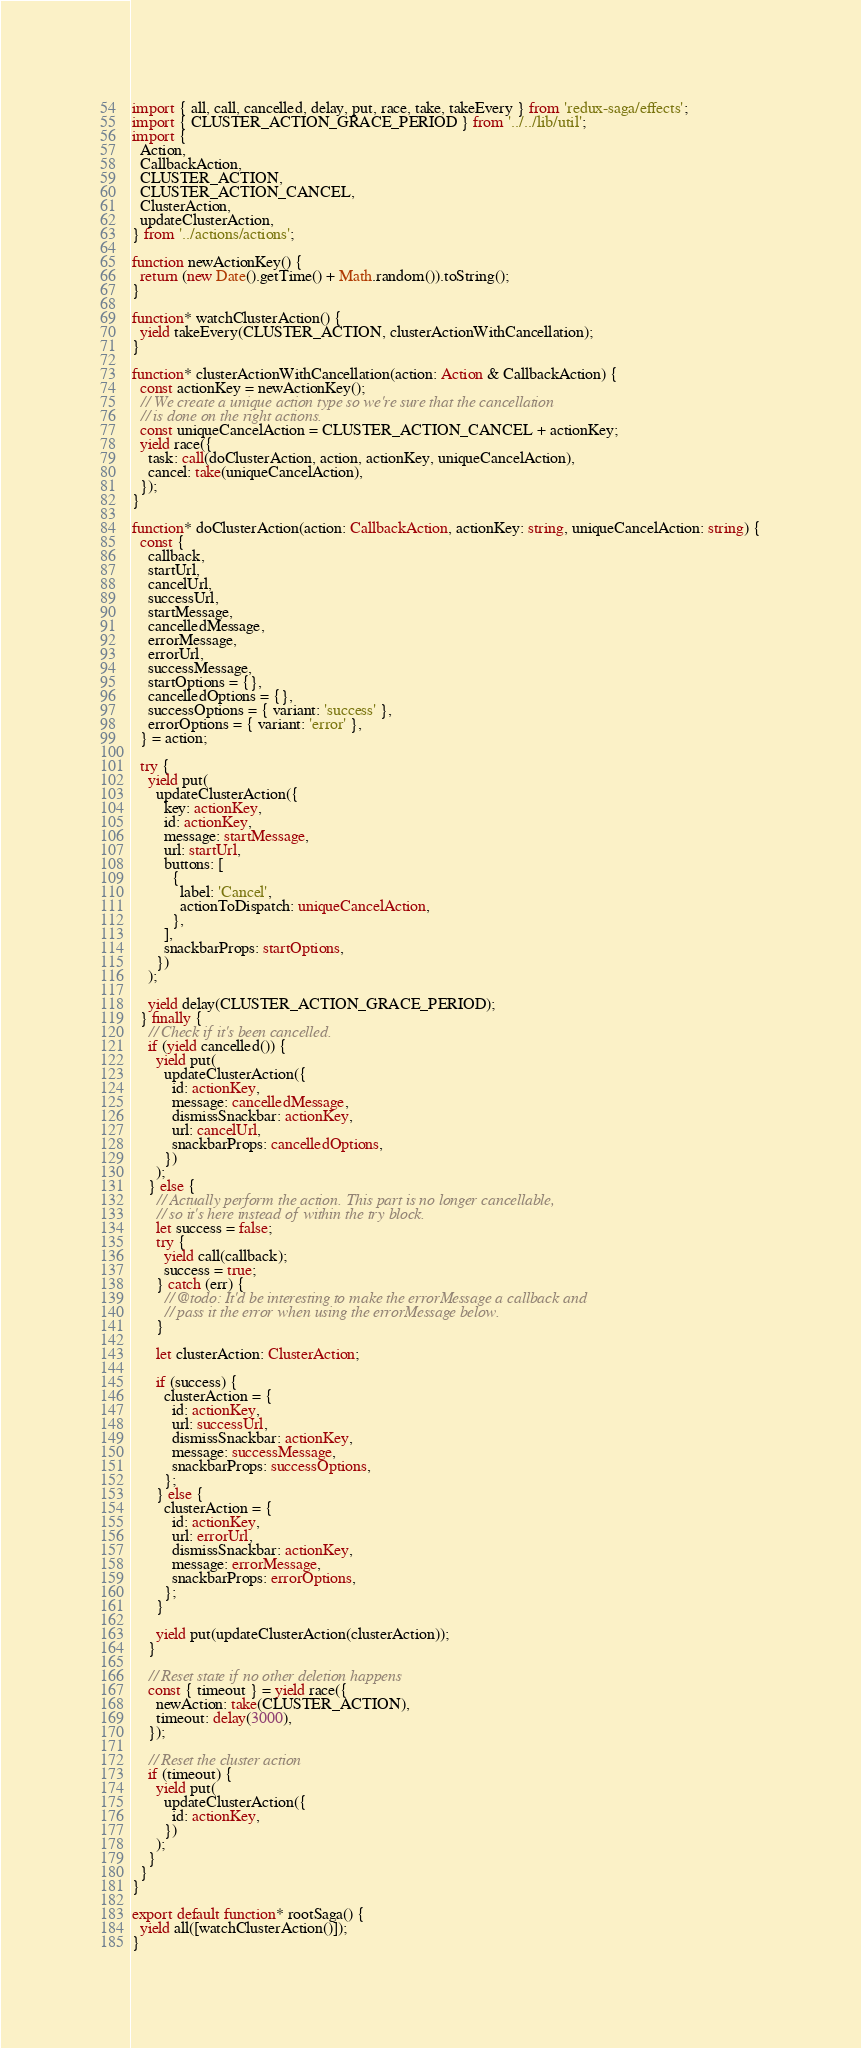<code> <loc_0><loc_0><loc_500><loc_500><_TypeScript_>import { all, call, cancelled, delay, put, race, take, takeEvery } from 'redux-saga/effects';
import { CLUSTER_ACTION_GRACE_PERIOD } from '../../lib/util';
import {
  Action,
  CallbackAction,
  CLUSTER_ACTION,
  CLUSTER_ACTION_CANCEL,
  ClusterAction,
  updateClusterAction,
} from '../actions/actions';

function newActionKey() {
  return (new Date().getTime() + Math.random()).toString();
}

function* watchClusterAction() {
  yield takeEvery(CLUSTER_ACTION, clusterActionWithCancellation);
}

function* clusterActionWithCancellation(action: Action & CallbackAction) {
  const actionKey = newActionKey();
  // We create a unique action type so we're sure that the cancellation
  // is done on the right actions.
  const uniqueCancelAction = CLUSTER_ACTION_CANCEL + actionKey;
  yield race({
    task: call(doClusterAction, action, actionKey, uniqueCancelAction),
    cancel: take(uniqueCancelAction),
  });
}

function* doClusterAction(action: CallbackAction, actionKey: string, uniqueCancelAction: string) {
  const {
    callback,
    startUrl,
    cancelUrl,
    successUrl,
    startMessage,
    cancelledMessage,
    errorMessage,
    errorUrl,
    successMessage,
    startOptions = {},
    cancelledOptions = {},
    successOptions = { variant: 'success' },
    errorOptions = { variant: 'error' },
  } = action;

  try {
    yield put(
      updateClusterAction({
        key: actionKey,
        id: actionKey,
        message: startMessage,
        url: startUrl,
        buttons: [
          {
            label: 'Cancel',
            actionToDispatch: uniqueCancelAction,
          },
        ],
        snackbarProps: startOptions,
      })
    );

    yield delay(CLUSTER_ACTION_GRACE_PERIOD);
  } finally {
    // Check if it's been cancelled.
    if (yield cancelled()) {
      yield put(
        updateClusterAction({
          id: actionKey,
          message: cancelledMessage,
          dismissSnackbar: actionKey,
          url: cancelUrl,
          snackbarProps: cancelledOptions,
        })
      );
    } else {
      // Actually perform the action. This part is no longer cancellable,
      // so it's here instead of within the try block.
      let success = false;
      try {
        yield call(callback);
        success = true;
      } catch (err) {
        // @todo: It'd be interesting to make the errorMessage a callback and
        // pass it the error when using the errorMessage below.
      }

      let clusterAction: ClusterAction;

      if (success) {
        clusterAction = {
          id: actionKey,
          url: successUrl,
          dismissSnackbar: actionKey,
          message: successMessage,
          snackbarProps: successOptions,
        };
      } else {
        clusterAction = {
          id: actionKey,
          url: errorUrl,
          dismissSnackbar: actionKey,
          message: errorMessage,
          snackbarProps: errorOptions,
        };
      }

      yield put(updateClusterAction(clusterAction));
    }

    // Reset state if no other deletion happens
    const { timeout } = yield race({
      newAction: take(CLUSTER_ACTION),
      timeout: delay(3000),
    });

    // Reset the cluster action
    if (timeout) {
      yield put(
        updateClusterAction({
          id: actionKey,
        })
      );
    }
  }
}

export default function* rootSaga() {
  yield all([watchClusterAction()]);
}
</code> 